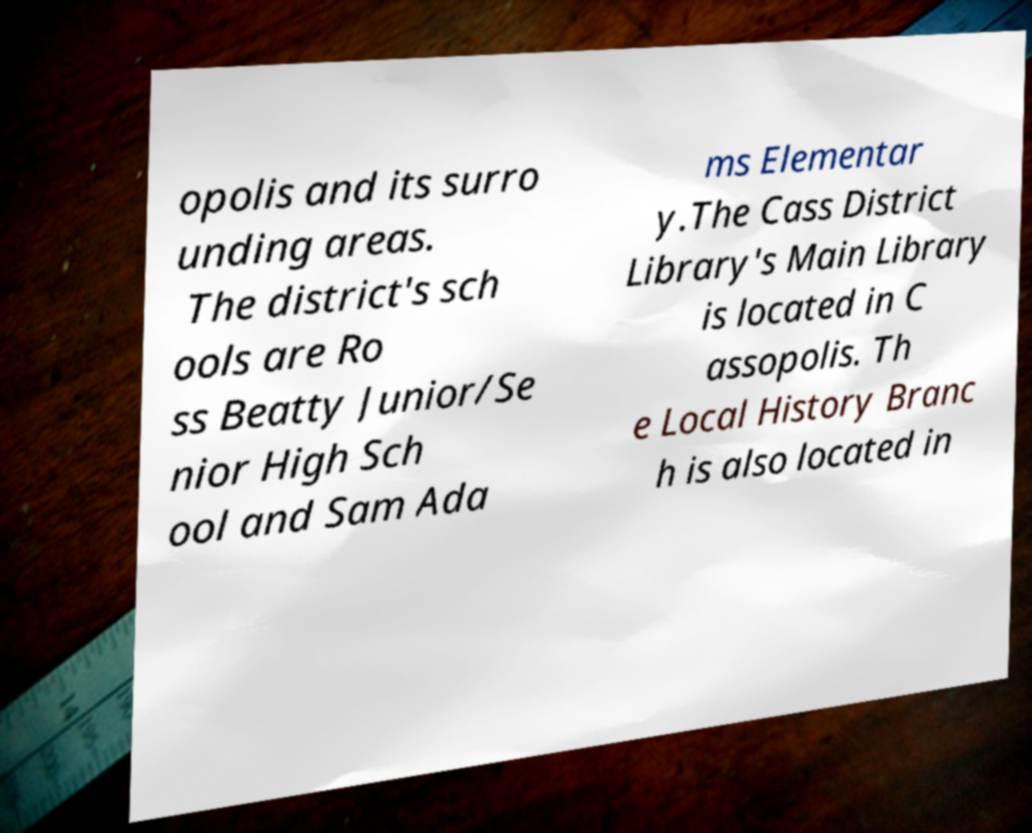I need the written content from this picture converted into text. Can you do that? opolis and its surro unding areas. The district's sch ools are Ro ss Beatty Junior/Se nior High Sch ool and Sam Ada ms Elementar y.The Cass District Library's Main Library is located in C assopolis. Th e Local History Branc h is also located in 